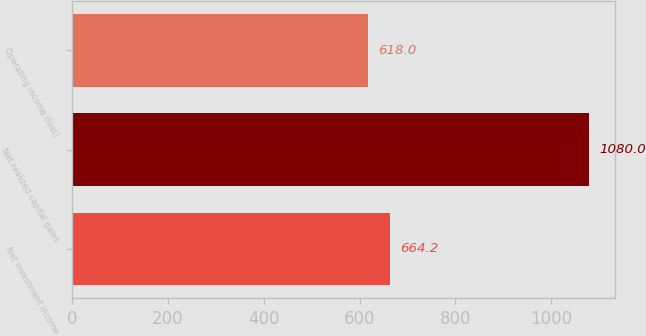<chart> <loc_0><loc_0><loc_500><loc_500><bar_chart><fcel>Net investment income<fcel>Net realized capital gains<fcel>Operating income (loss)<nl><fcel>664.2<fcel>1080<fcel>618<nl></chart> 